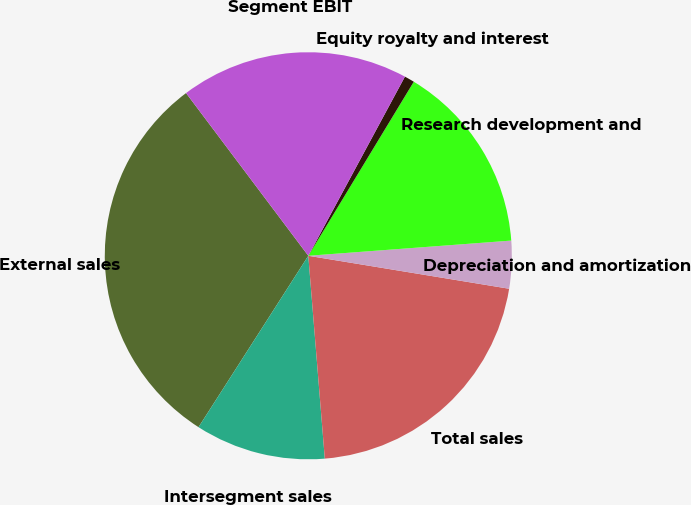<chart> <loc_0><loc_0><loc_500><loc_500><pie_chart><fcel>External sales<fcel>Intersegment sales<fcel>Total sales<fcel>Depreciation and amortization<fcel>Research development and<fcel>Equity royalty and interest<fcel>Segment EBIT<nl><fcel>30.68%<fcel>10.36%<fcel>21.12%<fcel>3.78%<fcel>15.14%<fcel>0.8%<fcel>18.13%<nl></chart> 